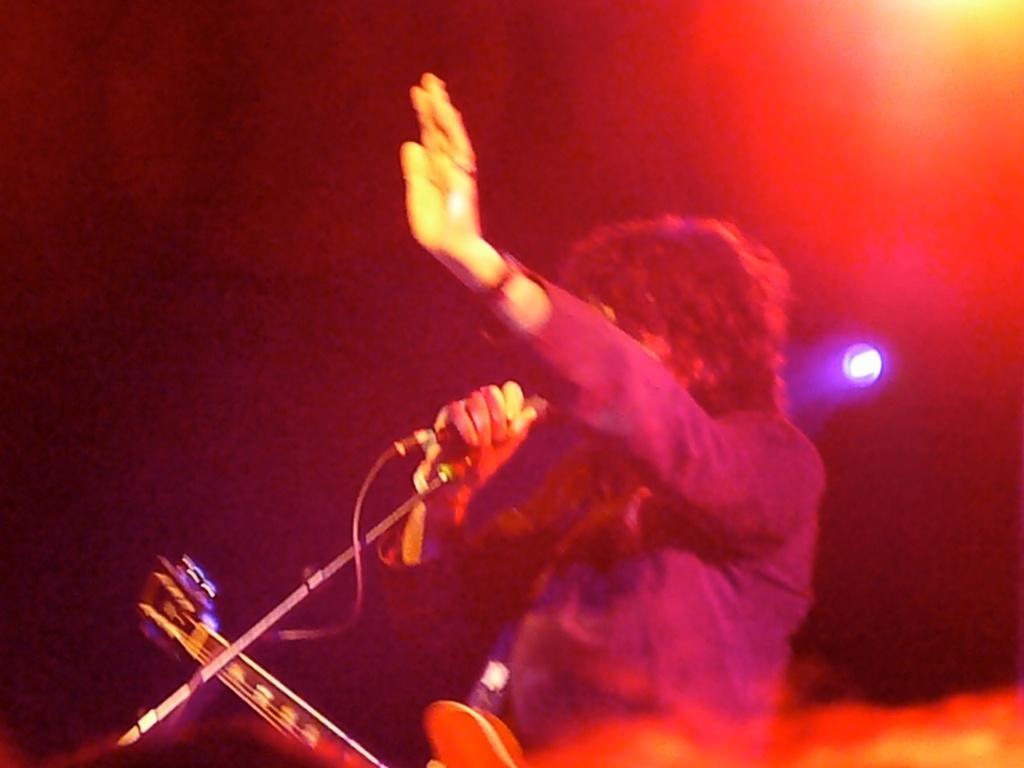Describe this image in one or two sentences. There is a person standing and holding a microphone and wire guitar. Background we can see light and it is dark. 